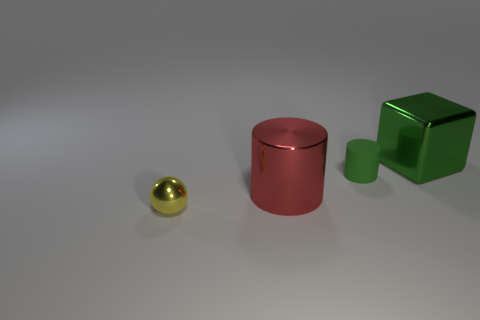What number of other objects are there of the same material as the tiny green object? There are no other objects of the same material as the tiny green object. The surrounding objects are made of different materials; for example, the small sphere is reflective and likely metallic, while the cylindrical object and cube have matte surfaces with distinct qualities apart from the tiny green object's appearance. 